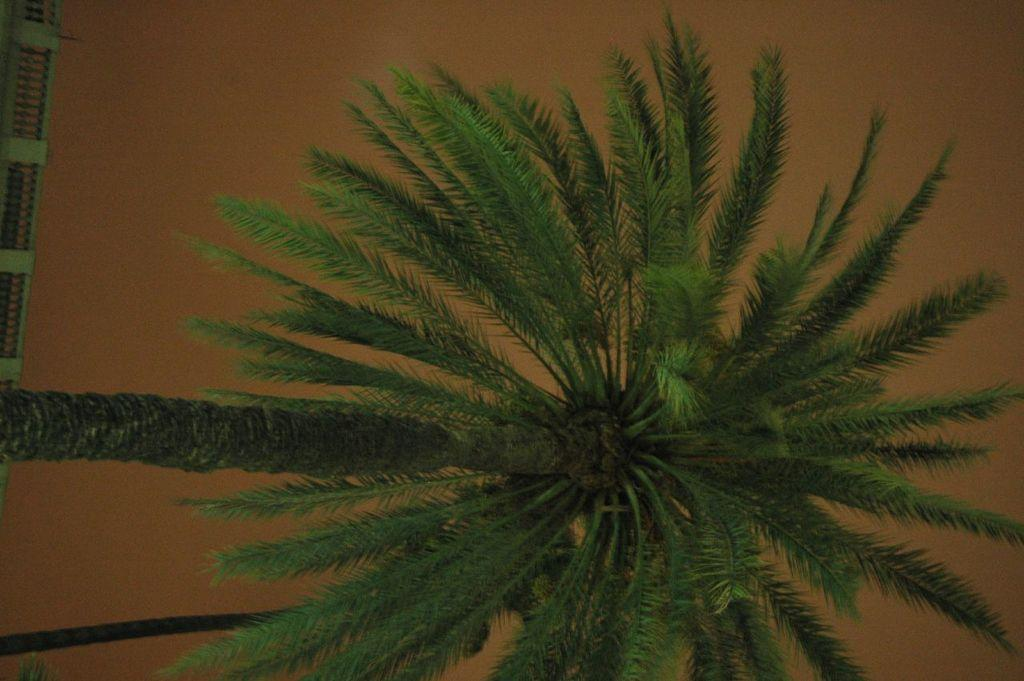What type of plant can be seen in the image? There is a tree in the image. What part of the natural environment is visible in the image? The sky is visible in the background of the image. How many deer can be seen grazing near the tree in the image? There are no deer present in the image; it only features a tree and the sky. What type of dust or steam can be seen coming from the tree in the image? There is no dust or steam visible coming from the tree in the image. 